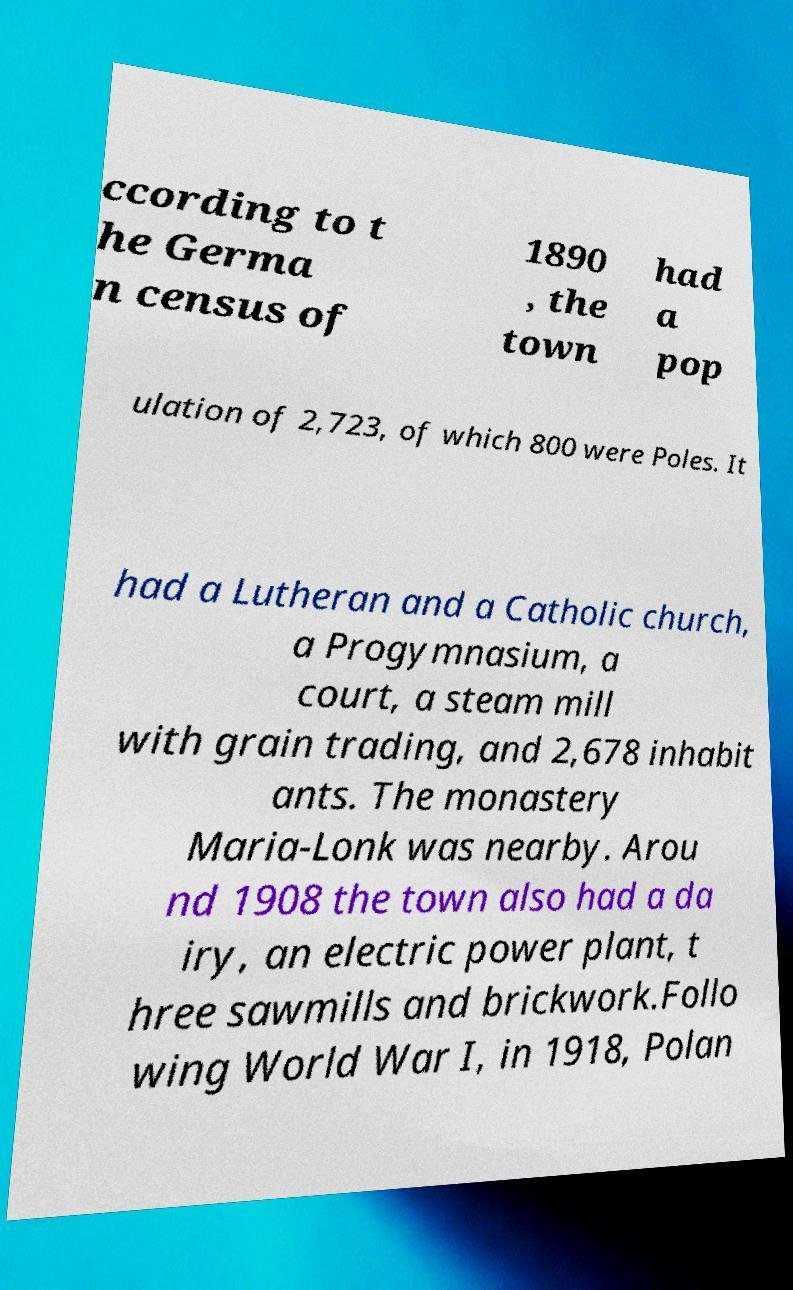Can you accurately transcribe the text from the provided image for me? ccording to t he Germa n census of 1890 , the town had a pop ulation of 2,723, of which 800 were Poles. It had a Lutheran and a Catholic church, a Progymnasium, a court, a steam mill with grain trading, and 2,678 inhabit ants. The monastery Maria-Lonk was nearby. Arou nd 1908 the town also had a da iry, an electric power plant, t hree sawmills and brickwork.Follo wing World War I, in 1918, Polan 